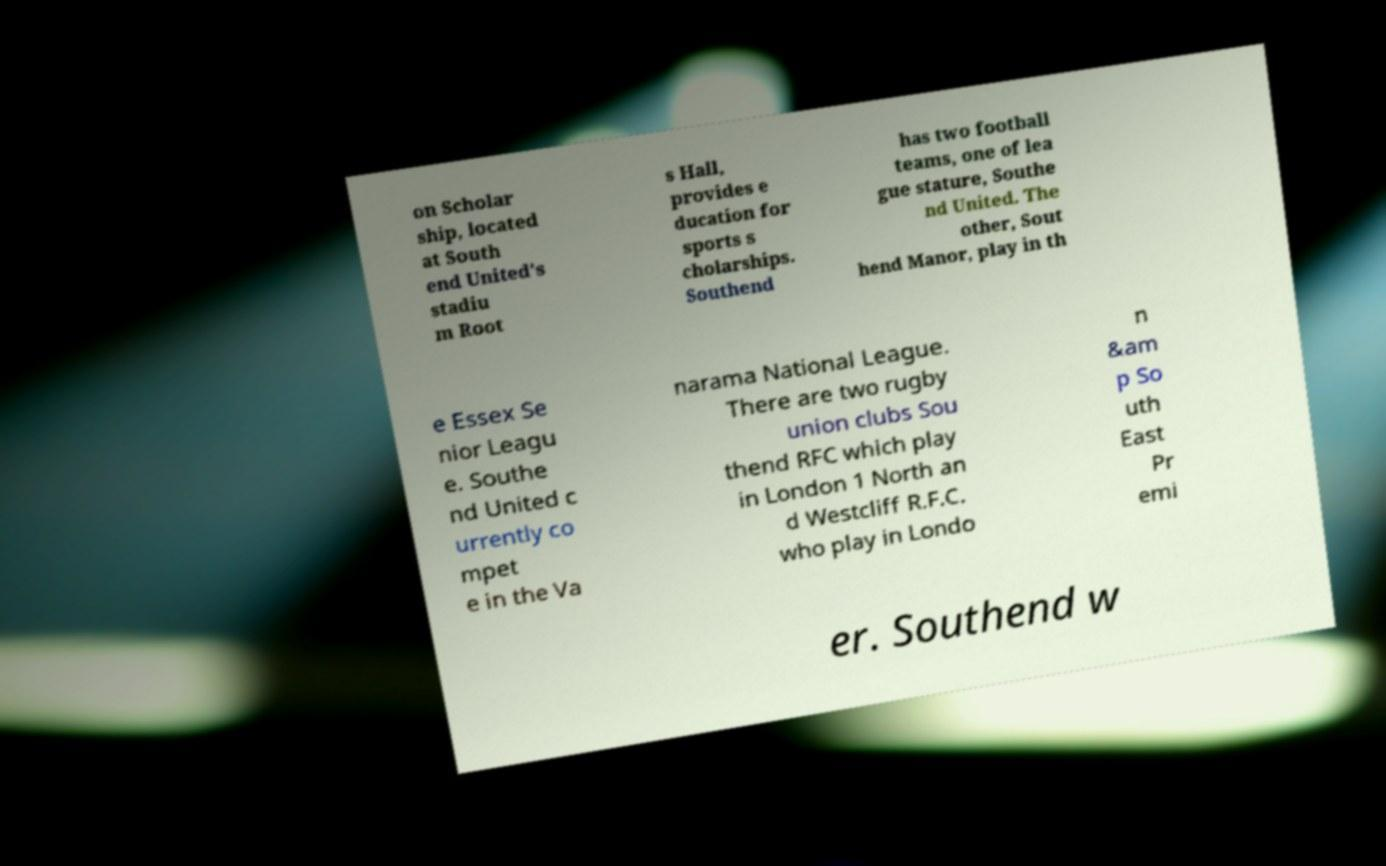I need the written content from this picture converted into text. Can you do that? on Scholar ship, located at South end United's stadiu m Root s Hall, provides e ducation for sports s cholarships. Southend has two football teams, one of lea gue stature, Southe nd United. The other, Sout hend Manor, play in th e Essex Se nior Leagu e. Southe nd United c urrently co mpet e in the Va narama National League. There are two rugby union clubs Sou thend RFC which play in London 1 North an d Westcliff R.F.C. who play in Londo n &am p So uth East Pr emi er. Southend w 